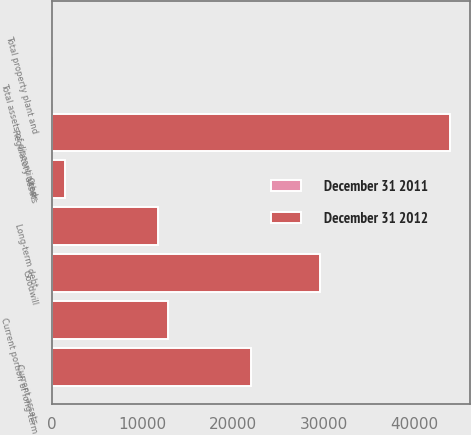Convert chart to OTSL. <chart><loc_0><loc_0><loc_500><loc_500><stacked_bar_chart><ecel><fcel>Total property plant and<fcel>Current assets<fcel>Regulatory assets<fcel>Goodwill<fcel>Other<fcel>Total assets of discontinued<fcel>Long-term debt<fcel>Current portion of long-term<nl><fcel>December 31 2011<fcel>0<fcel>0<fcel>0<fcel>0<fcel>0<fcel>0<fcel>0<fcel>0<nl><fcel>December 31 2012<fcel>0<fcel>21906<fcel>43849<fcel>29608<fcel>1472<fcel>0<fcel>11697<fcel>12839<nl></chart> 